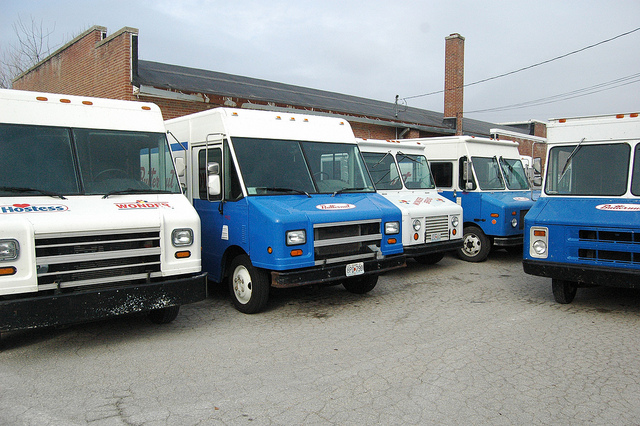Please identify all text content in this image. Hostees 